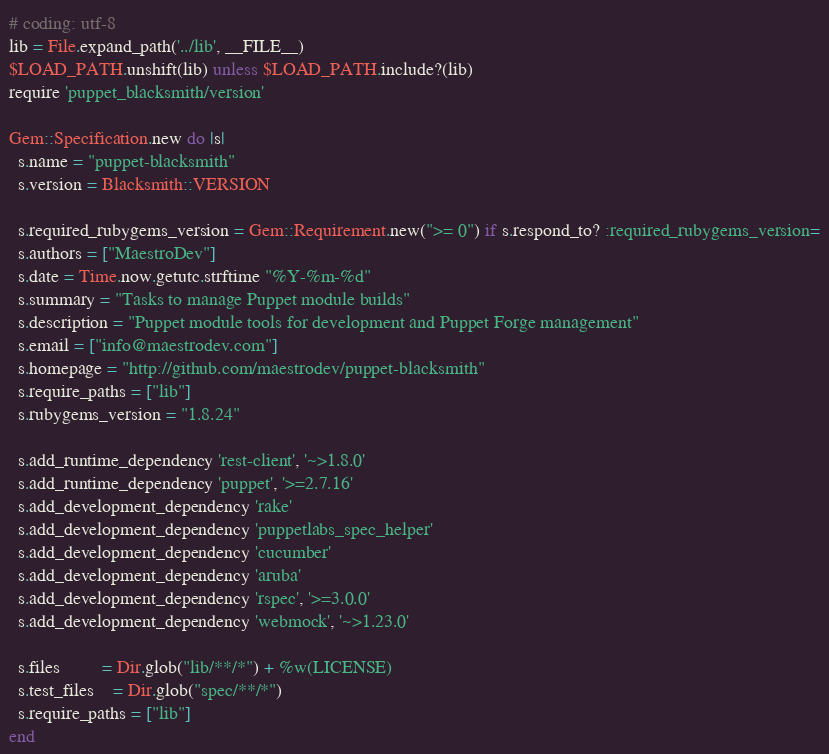<code> <loc_0><loc_0><loc_500><loc_500><_Ruby_># coding: utf-8
lib = File.expand_path('../lib', __FILE__)
$LOAD_PATH.unshift(lib) unless $LOAD_PATH.include?(lib)
require 'puppet_blacksmith/version'

Gem::Specification.new do |s|
  s.name = "puppet-blacksmith"
  s.version = Blacksmith::VERSION

  s.required_rubygems_version = Gem::Requirement.new(">= 0") if s.respond_to? :required_rubygems_version=
  s.authors = ["MaestroDev"]
  s.date = Time.now.getutc.strftime "%Y-%m-%d"
  s.summary = "Tasks to manage Puppet module builds"
  s.description = "Puppet module tools for development and Puppet Forge management"
  s.email = ["info@maestrodev.com"]
  s.homepage = "http://github.com/maestrodev/puppet-blacksmith"
  s.require_paths = ["lib"]
  s.rubygems_version = "1.8.24"

  s.add_runtime_dependency 'rest-client', '~>1.8.0'
  s.add_runtime_dependency 'puppet', '>=2.7.16'
  s.add_development_dependency 'rake'
  s.add_development_dependency 'puppetlabs_spec_helper'
  s.add_development_dependency 'cucumber'
  s.add_development_dependency 'aruba'
  s.add_development_dependency 'rspec', '>=3.0.0'
  s.add_development_dependency 'webmock', '~>1.23.0'

  s.files         = Dir.glob("lib/**/*") + %w(LICENSE)
  s.test_files    = Dir.glob("spec/**/*")
  s.require_paths = ["lib"]
end
</code> 